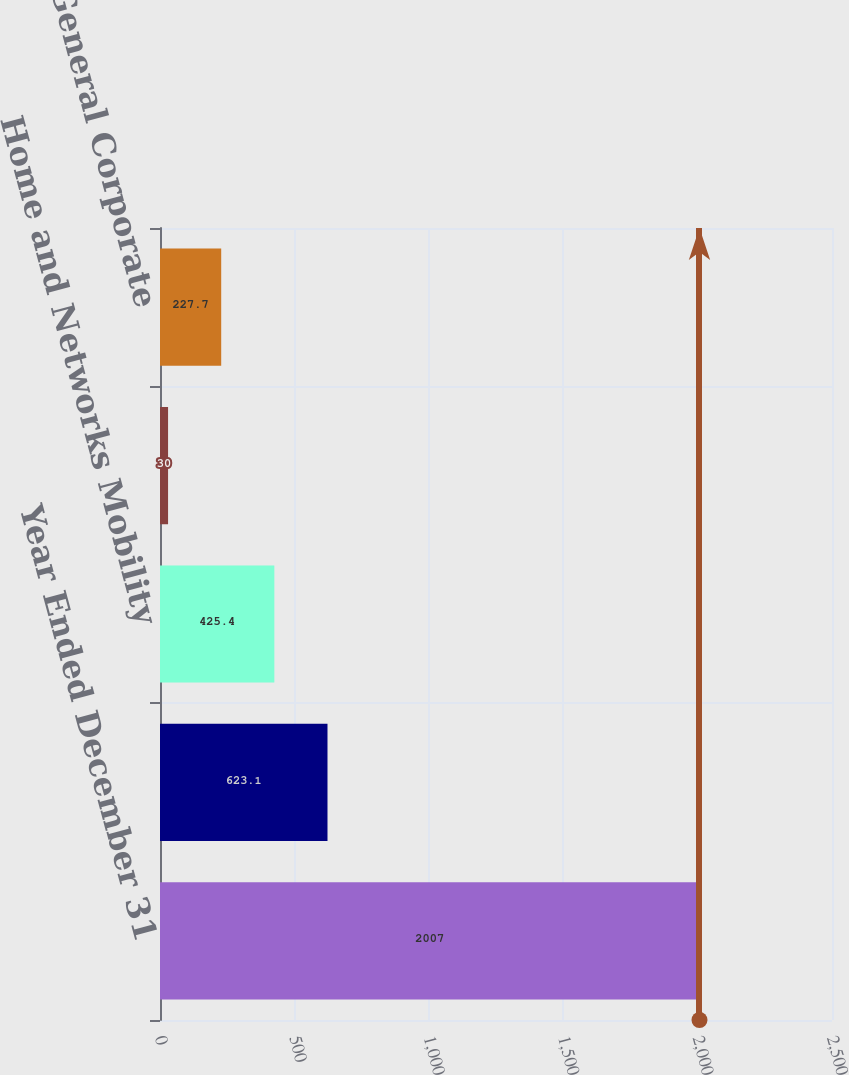Convert chart to OTSL. <chart><loc_0><loc_0><loc_500><loc_500><bar_chart><fcel>Year Ended December 31<fcel>Mobile Devices<fcel>Home and Networks Mobility<fcel>Enterprise Mobility Solutions<fcel>General Corporate<nl><fcel>2007<fcel>623.1<fcel>425.4<fcel>30<fcel>227.7<nl></chart> 